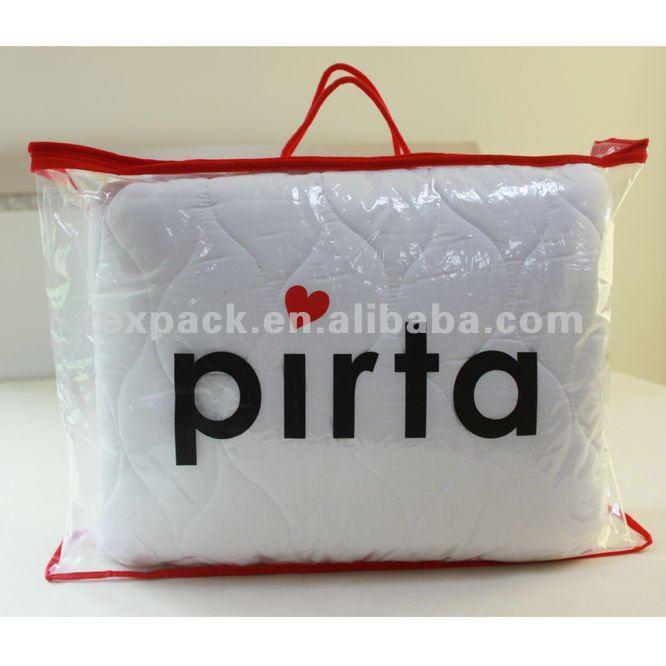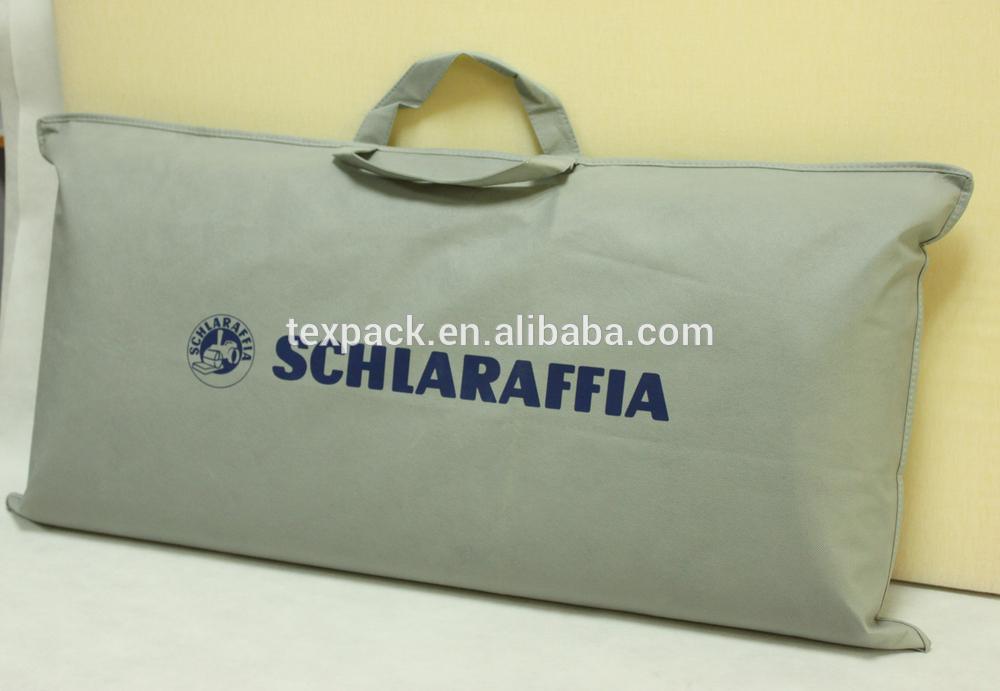The first image is the image on the left, the second image is the image on the right. Considering the images on both sides, is "All four bags are translucent and stuffed tightly with a pillow." valid? Answer yes or no. No. The first image is the image on the left, the second image is the image on the right. Assess this claim about the two images: "An image shows a pillow in a transparent bag with a black handle and black edges.". Correct or not? Answer yes or no. No. 